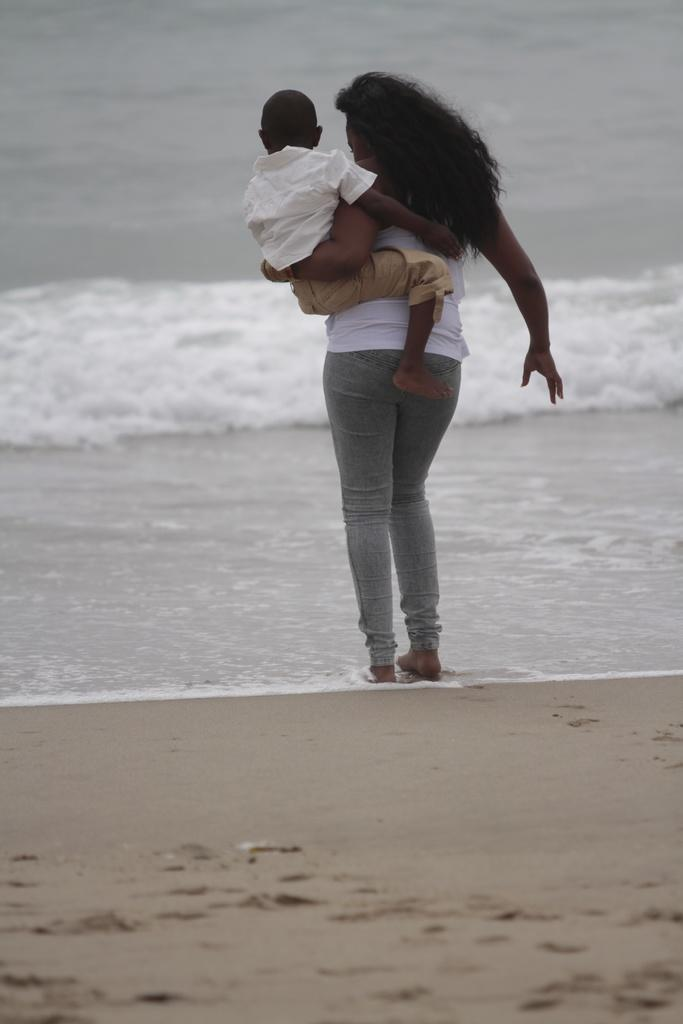What is the main setting of the image? The image depicts a sea. Can you describe the people in the image? There is a woman standing in the image, and she is holding a boy. What type of surface can be seen in the image? There is water and sand visible in the image. Where is the ticket booth located in the image? There is no ticket booth present in the image. Can you see any snakes in the image? There are no snakes visible in the image. 